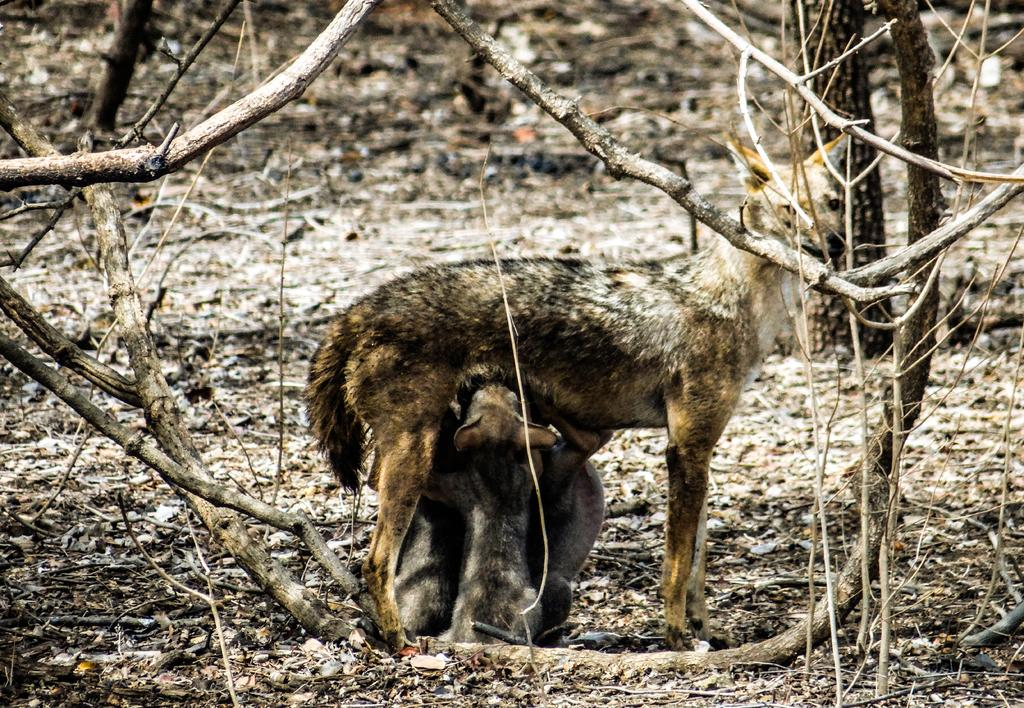What types of living organisms can be seen in the image? There are animals in the image. What natural objects can be seen in the image? There are twigs in the image. What type of zinc is visible in the image? There is no zinc present in the image. What color is the curtain in the image? There is no curtain present in the image. 